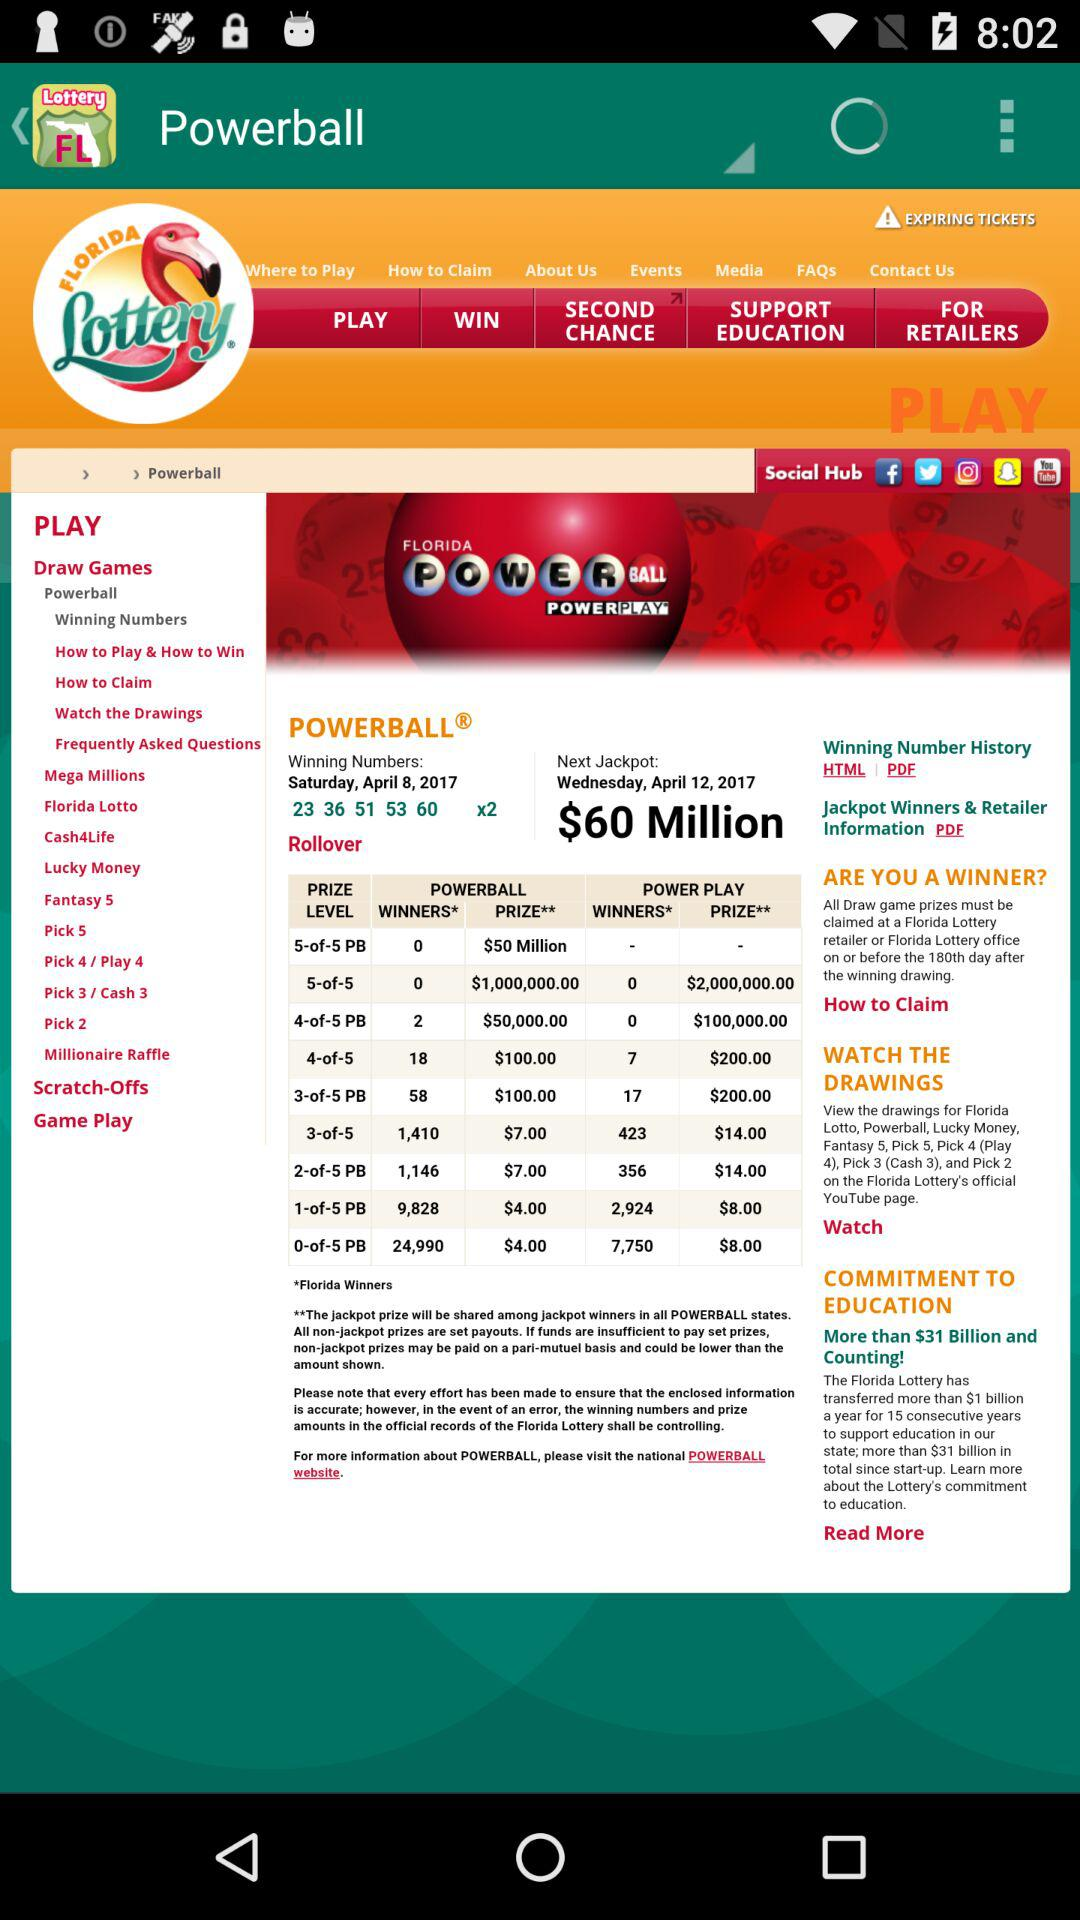On which date will the next jackpot be opened? The next jackpot will be opened on Wednesday, April 12, 2017. 